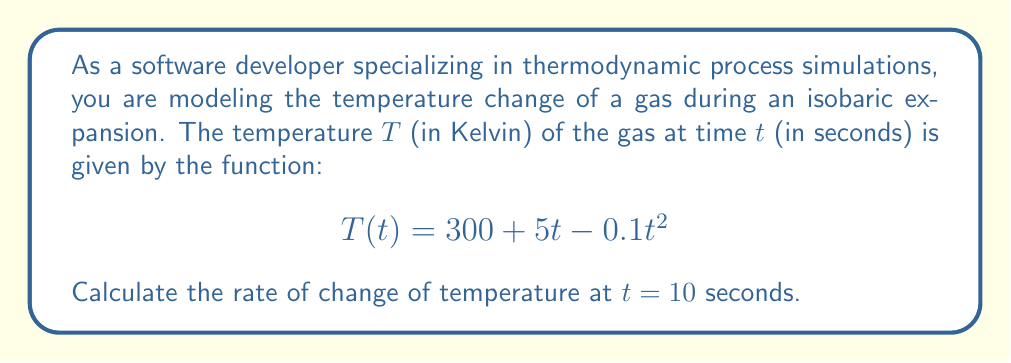Give your solution to this math problem. To solve this problem, we need to use derivatives to find the rate of change of temperature with respect to time. Here's a step-by-step approach:

1) The rate of change of temperature with respect to time is given by the first derivative of the temperature function $T(t)$.

2) Let's find the derivative of $T(t)$:
   
   $$T(t) = 300 + 5t - 0.1t^2$$
   
   $$\frac{dT}{dt} = 0 + 5 - 0.2t$$
   
   $$\frac{dT}{dt} = 5 - 0.2t$$

3) This derivative function $\frac{dT}{dt}$ represents the instantaneous rate of change of temperature at any given time $t$.

4) To find the rate of change at $t = 10$ seconds, we substitute $t = 10$ into our derivative function:

   $$\frac{dT}{dt}\bigg|_{t=10} = 5 - 0.2(10)$$
   
   $$\frac{dT}{dt}\bigg|_{t=10} = 5 - 2 = 3$$

5) The units of this rate of change will be Kelvin per second (K/s), as we're measuring the change in temperature (K) over time (s).
Answer: The rate of change of temperature at $t = 10$ seconds is $3$ K/s. 